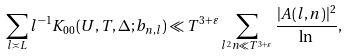<formula> <loc_0><loc_0><loc_500><loc_500>\sum _ { l \asymp L } l ^ { - 1 } K _ { 0 0 } ( U , T , \Delta ; b _ { n , l } ) \ll T ^ { 3 + \varepsilon } \sum _ { l ^ { 2 } n \ll T ^ { 3 + \varepsilon } } \frac { | A ( l , n ) | ^ { 2 } } { \ln } ,</formula> 